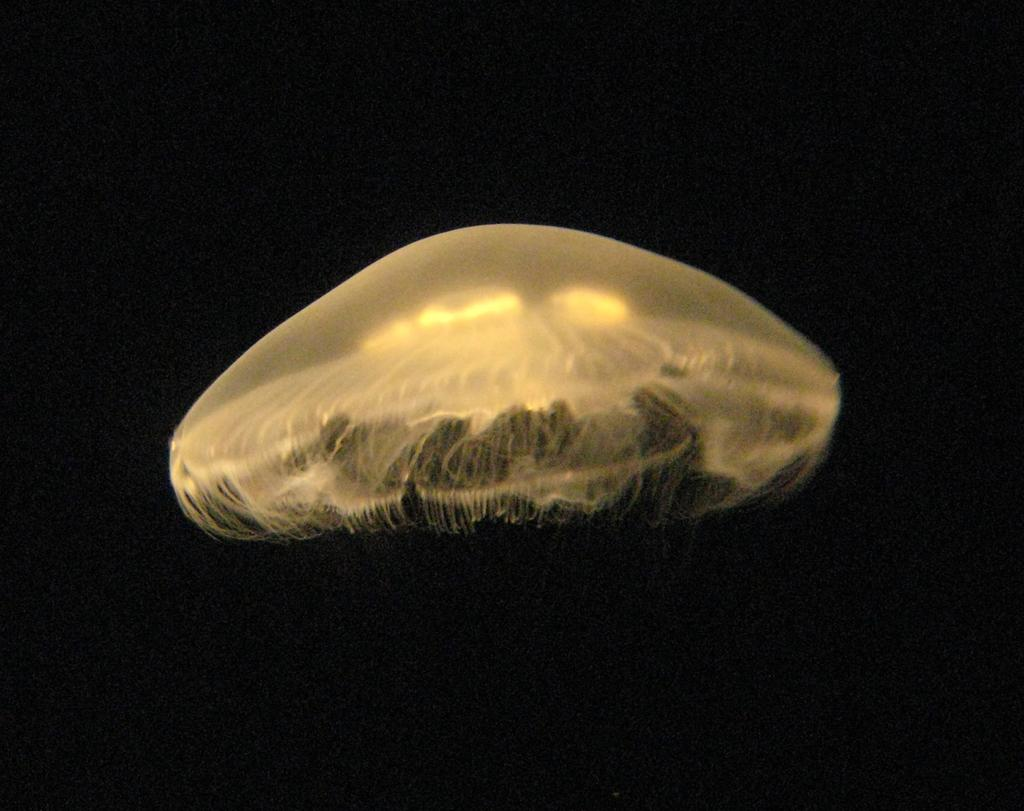What is the main subject of the image? There is a jellyfish in the image. What can be observed about the background of the image? The background of the image is dark. What type of tooth is visible in the image? There is no tooth present in the image; it features a jellyfish. What kind of board can be seen in the image? There is no board present in the image; it features a jellyfish. 